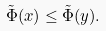<formula> <loc_0><loc_0><loc_500><loc_500>\tilde { \Phi } ( x ) \leq \tilde { \Phi } ( y ) .</formula> 